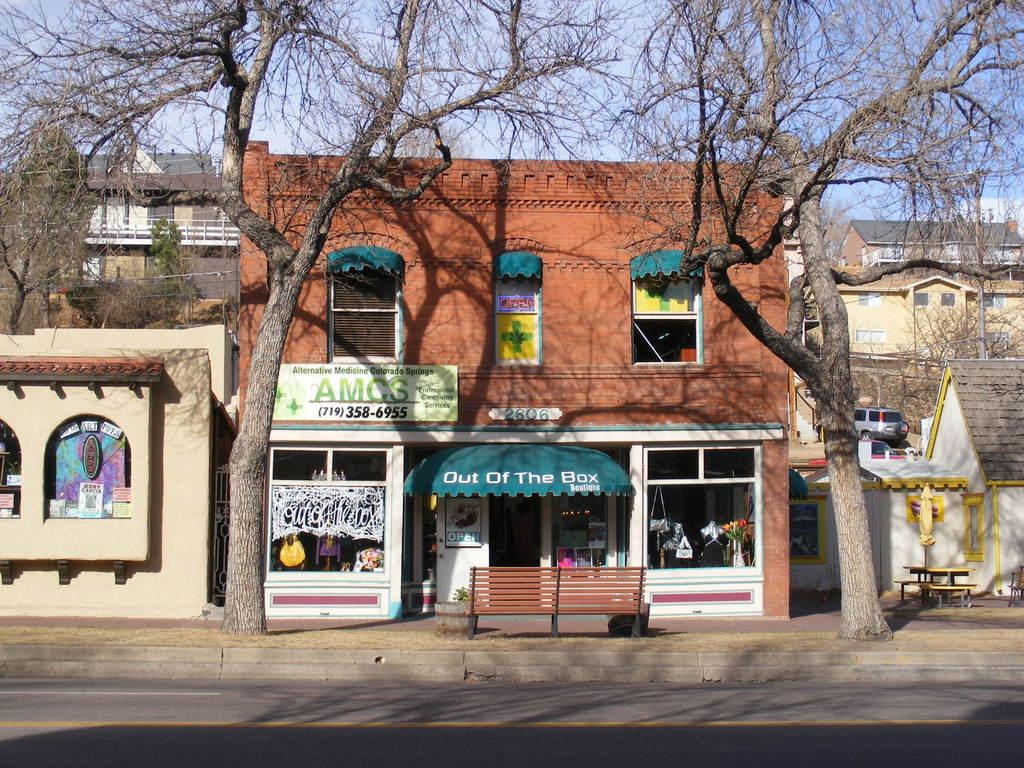What is located in the foreground of the image? There is a road in the foreground of the image. What can be seen in the background of the image? In the background of the image, there are stoles, at least one building, benches, trees, a vehicle, and the sky. How many elements are present in the background of the image? There are seven elements present in the background: stoles, a building, benches, trees, a vehicle, and the sky. What type of structures are visible in the background of the image? There is at least one building visible in the background of the image. What type of bubble can be seen floating near the building in the image? There is no bubble present in the image. 